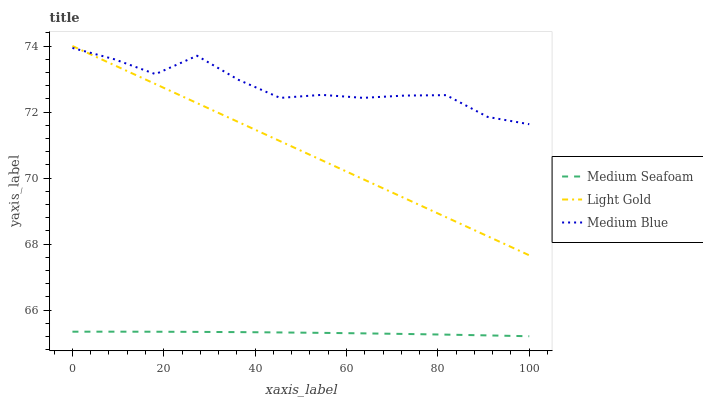Does Medium Seafoam have the minimum area under the curve?
Answer yes or no. Yes. Does Medium Blue have the maximum area under the curve?
Answer yes or no. Yes. Does Light Gold have the minimum area under the curve?
Answer yes or no. No. Does Light Gold have the maximum area under the curve?
Answer yes or no. No. Is Light Gold the smoothest?
Answer yes or no. Yes. Is Medium Blue the roughest?
Answer yes or no. Yes. Is Medium Seafoam the smoothest?
Answer yes or no. No. Is Medium Seafoam the roughest?
Answer yes or no. No. Does Medium Seafoam have the lowest value?
Answer yes or no. Yes. Does Light Gold have the lowest value?
Answer yes or no. No. Does Light Gold have the highest value?
Answer yes or no. Yes. Does Medium Seafoam have the highest value?
Answer yes or no. No. Is Medium Seafoam less than Medium Blue?
Answer yes or no. Yes. Is Medium Blue greater than Medium Seafoam?
Answer yes or no. Yes. Does Light Gold intersect Medium Blue?
Answer yes or no. Yes. Is Light Gold less than Medium Blue?
Answer yes or no. No. Is Light Gold greater than Medium Blue?
Answer yes or no. No. Does Medium Seafoam intersect Medium Blue?
Answer yes or no. No. 